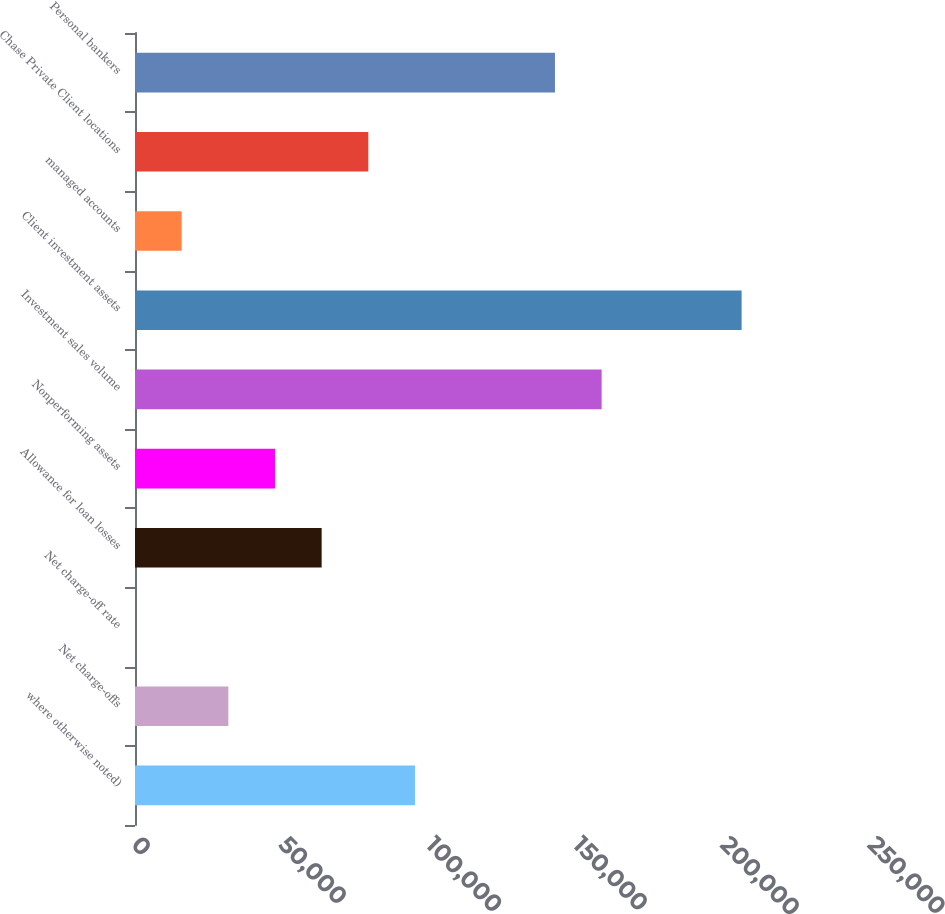Convert chart. <chart><loc_0><loc_0><loc_500><loc_500><bar_chart><fcel>where otherwise noted)<fcel>Net charge-offs<fcel>Net charge-off rate<fcel>Allowance for loan losses<fcel>Nonperforming assets<fcel>Investment sales volume<fcel>Client investment assets<fcel>managed accounts<fcel>Chase Private Client locations<fcel>Personal bankers<nl><fcel>95102.1<fcel>31702.2<fcel>2.27<fcel>63402.2<fcel>47552.2<fcel>158502<fcel>206052<fcel>15852.2<fcel>79252.1<fcel>142652<nl></chart> 